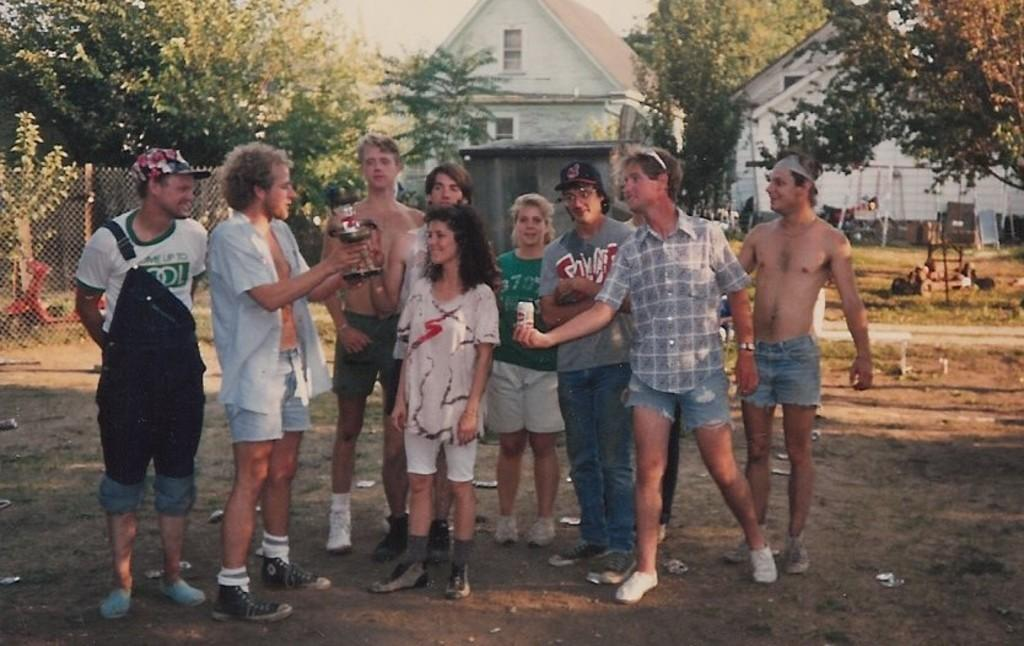What is happening in the middle of the image? There is a group of people standing in the middle of the image. What can be seen on the left side of the image? There is a vehicle and an iron net on the left side of the image. What is visible in the background of the image? There are trees and houses in the background of the image. How many pies are being served by the laborer in the image? There is no laborer or pies present in the image. What is the minister doing in the image? There is no minister present in the image. 